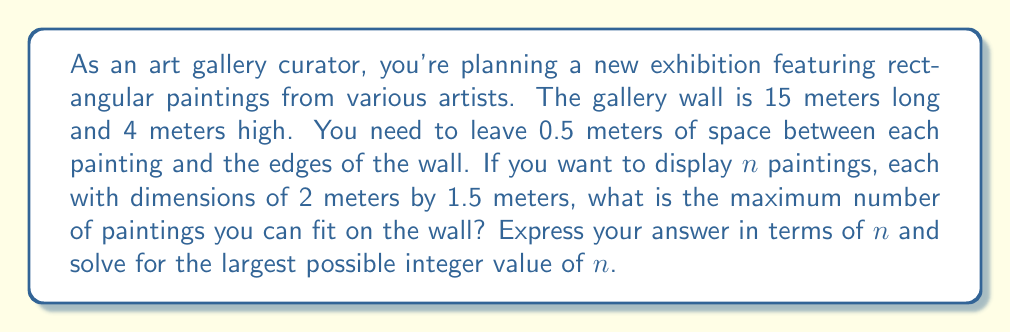Give your solution to this math problem. Let's approach this step-by-step:

1) First, let's calculate the usable wall space:
   - Width: $15 - (2 \times 0.5) = 14$ meters
   - Height: $4 - (2 \times 0.5) = 3$ meters

2) Now, let's consider how the paintings will be arranged:
   - Each painting is 2 meters wide and 1.5 meters high
   - We need 0.5 meters between each painting

3) Let's create an inequality for the width:
   $$2n + 0.5(n-1) \leq 14$$
   This accounts for $n$ paintings of 2 meters each, plus $(n-1)$ spaces of 0.5 meters between them.

4) Simplify the inequality:
   $$2n + 0.5n - 0.5 \leq 14$$
   $$2.5n - 0.5 \leq 14$$
   $$2.5n \leq 14.5$$
   $$n \leq 5.8$$

5) Since $n$ must be an integer, the maximum value for $n$ is 5.

6) Let's verify if 5 paintings fit vertically:
   - 5 paintings of 1.5 meters each plus 4 spaces of 0.5 meters = $5(1.5) + 4(0.5) = 9.5$ meters
   This is greater than our usable height of 3 meters, so we need to arrange them in two rows.

7) With two rows, we can fit a maximum of 10 paintings (5 in each row).

Therefore, the maximum number of paintings that can fit on the wall is 10.
Answer: The maximum number of paintings that can be displayed is 10. 